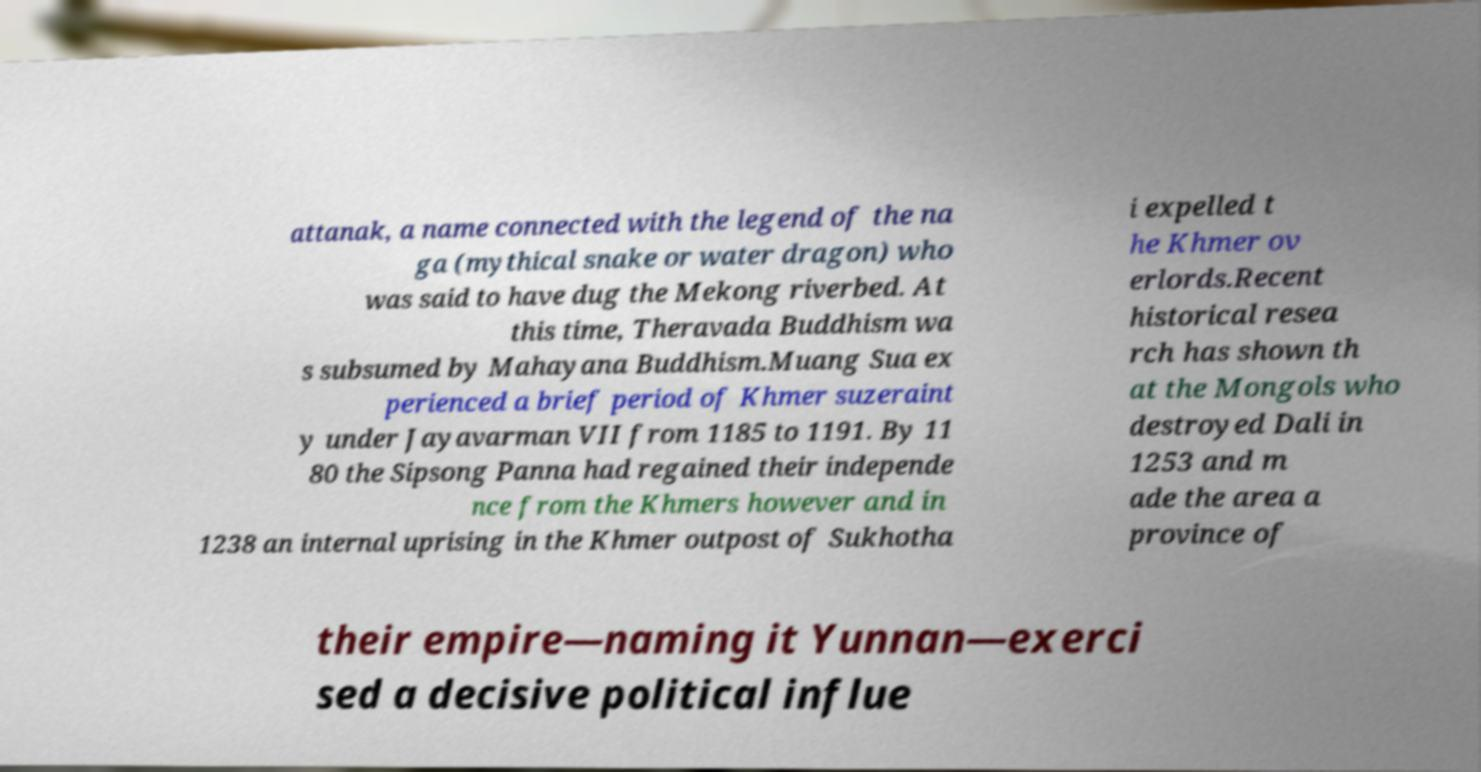I need the written content from this picture converted into text. Can you do that? attanak, a name connected with the legend of the na ga (mythical snake or water dragon) who was said to have dug the Mekong riverbed. At this time, Theravada Buddhism wa s subsumed by Mahayana Buddhism.Muang Sua ex perienced a brief period of Khmer suzeraint y under Jayavarman VII from 1185 to 1191. By 11 80 the Sipsong Panna had regained their independe nce from the Khmers however and in 1238 an internal uprising in the Khmer outpost of Sukhotha i expelled t he Khmer ov erlords.Recent historical resea rch has shown th at the Mongols who destroyed Dali in 1253 and m ade the area a province of their empire—naming it Yunnan—exerci sed a decisive political influe 